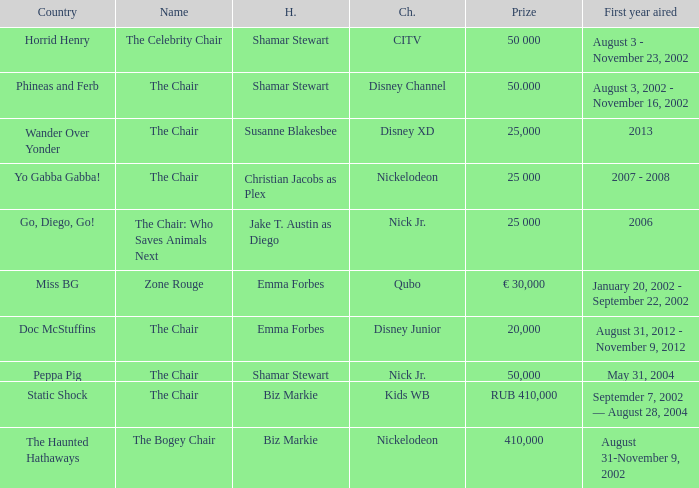Can you parse all the data within this table? {'header': ['Country', 'Name', 'H.', 'Ch.', 'Prize', 'First year aired'], 'rows': [['Horrid Henry', 'The Celebrity Chair', 'Shamar Stewart', 'CITV', '50 000', 'August 3 - November 23, 2002'], ['Phineas and Ferb', 'The Chair', 'Shamar Stewart', 'Disney Channel', '50.000', 'August 3, 2002 - November 16, 2002'], ['Wander Over Yonder', 'The Chair', 'Susanne Blakesbee', 'Disney XD', '25,000', '2013'], ['Yo Gabba Gabba!', 'The Chair', 'Christian Jacobs as Plex', 'Nickelodeon', '25 000', '2007 - 2008'], ['Go, Diego, Go!', 'The Chair: Who Saves Animals Next', 'Jake T. Austin as Diego', 'Nick Jr.', '25 000', '2006'], ['Miss BG', 'Zone Rouge', 'Emma Forbes', 'Qubo', '€ 30,000', 'January 20, 2002 - September 22, 2002'], ['Doc McStuffins', 'The Chair', 'Emma Forbes', 'Disney Junior', '20,000', 'August 31, 2012 - November 9, 2012'], ['Peppa Pig', 'The Chair', 'Shamar Stewart', 'Nick Jr.', '50,000', 'May 31, 2004'], ['Static Shock', 'The Chair', 'Biz Markie', 'Kids WB', 'RUB 410,000', 'Septemder 7, 2002 — August 28, 2004'], ['The Haunted Hathaways', 'The Bogey Chair', 'Biz Markie', 'Nickelodeon', '410,000', 'August 31-November 9, 2002']]} What was the first year that had a prize of 50,000? May 31, 2004. 